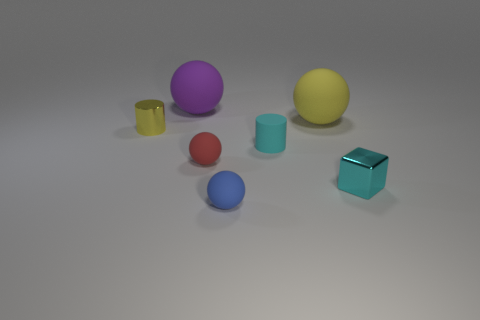Subtract all tiny blue matte spheres. How many spheres are left? 3 Add 1 purple rubber cylinders. How many objects exist? 8 Subtract 3 spheres. How many spheres are left? 1 Subtract all balls. How many objects are left? 3 Subtract all blue spheres. How many red cylinders are left? 0 Subtract all red spheres. How many spheres are left? 3 Subtract 0 cyan balls. How many objects are left? 7 Subtract all green cylinders. Subtract all brown spheres. How many cylinders are left? 2 Subtract all red rubber objects. Subtract all small rubber cylinders. How many objects are left? 5 Add 7 small blue matte spheres. How many small blue matte spheres are left? 8 